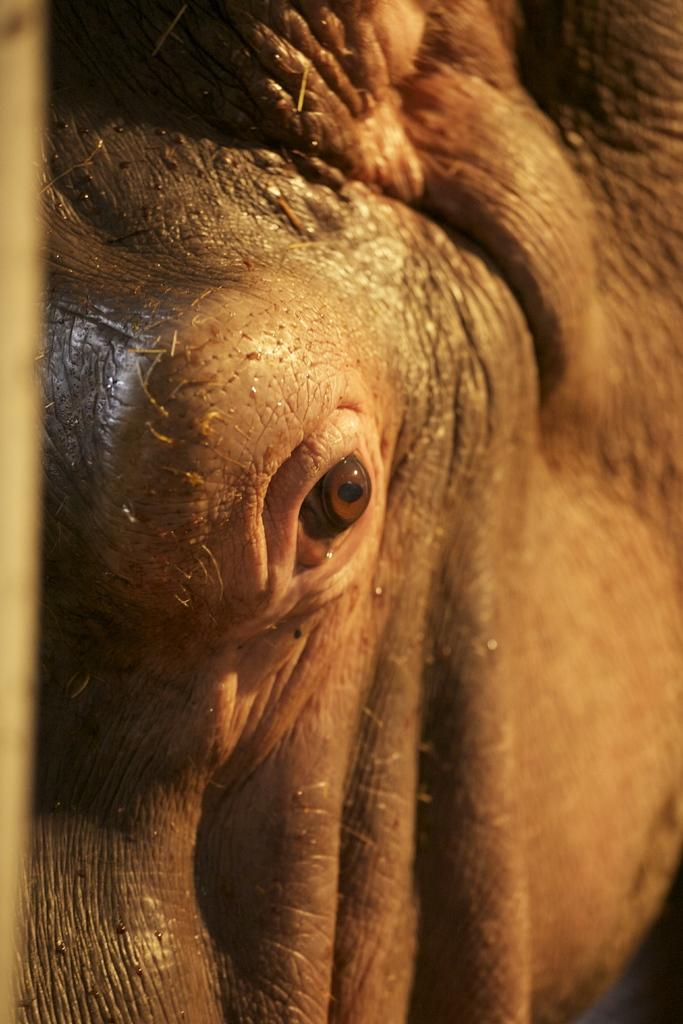What is the main subject of the image? The main subject of the image is the eye of an animal. How many letters are present in the image? There are no letters present in the image; it only features the eye of an animal. What emotion can be observed in the animal's eye in the image? The image does not convey any emotions, as it only shows the eye of an animal. 